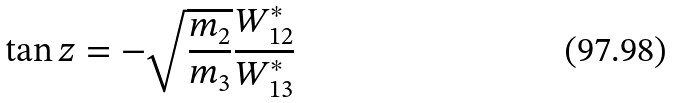<formula> <loc_0><loc_0><loc_500><loc_500>\tan z = - \sqrt { \frac { m _ { 2 } } { m _ { 3 } } } \frac { W _ { 1 2 } ^ { \ast } } { W _ { 1 3 } ^ { \ast } }</formula> 